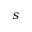Convert formula to latex. <formula><loc_0><loc_0><loc_500><loc_500>s</formula> 